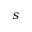Convert formula to latex. <formula><loc_0><loc_0><loc_500><loc_500>s</formula> 